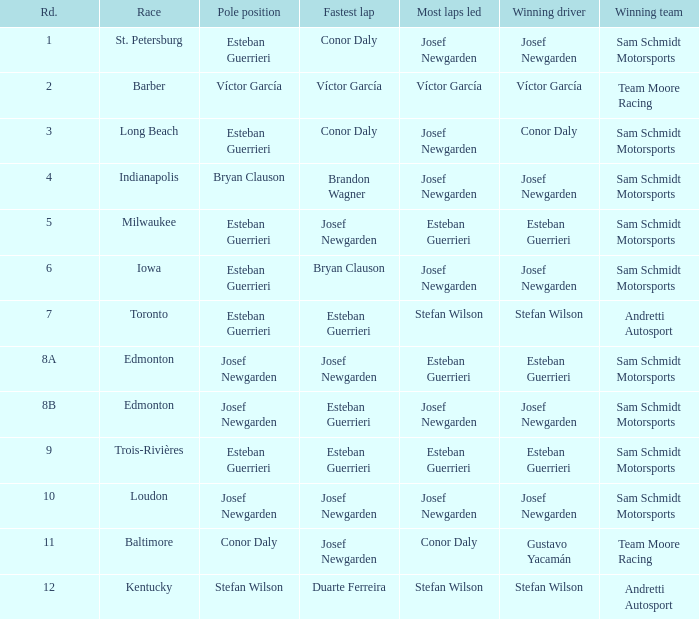When josef newgarden led the most laps in edmonton, who achieved the quickest lap(s)? Esteban Guerrieri. 